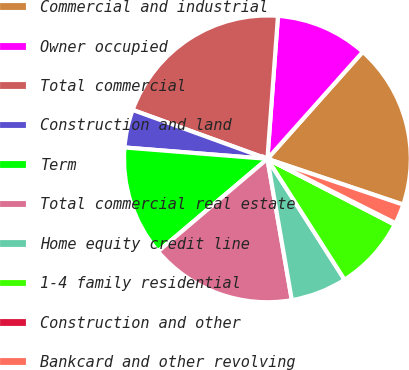Convert chart to OTSL. <chart><loc_0><loc_0><loc_500><loc_500><pie_chart><fcel>Commercial and industrial<fcel>Owner occupied<fcel>Total commercial<fcel>Construction and land<fcel>Term<fcel>Total commercial real estate<fcel>Home equity credit line<fcel>1-4 family residential<fcel>Construction and other<fcel>Bankcard and other revolving<nl><fcel>18.59%<fcel>10.41%<fcel>20.63%<fcel>4.28%<fcel>12.45%<fcel>16.54%<fcel>6.32%<fcel>8.36%<fcel>0.19%<fcel>2.23%<nl></chart> 